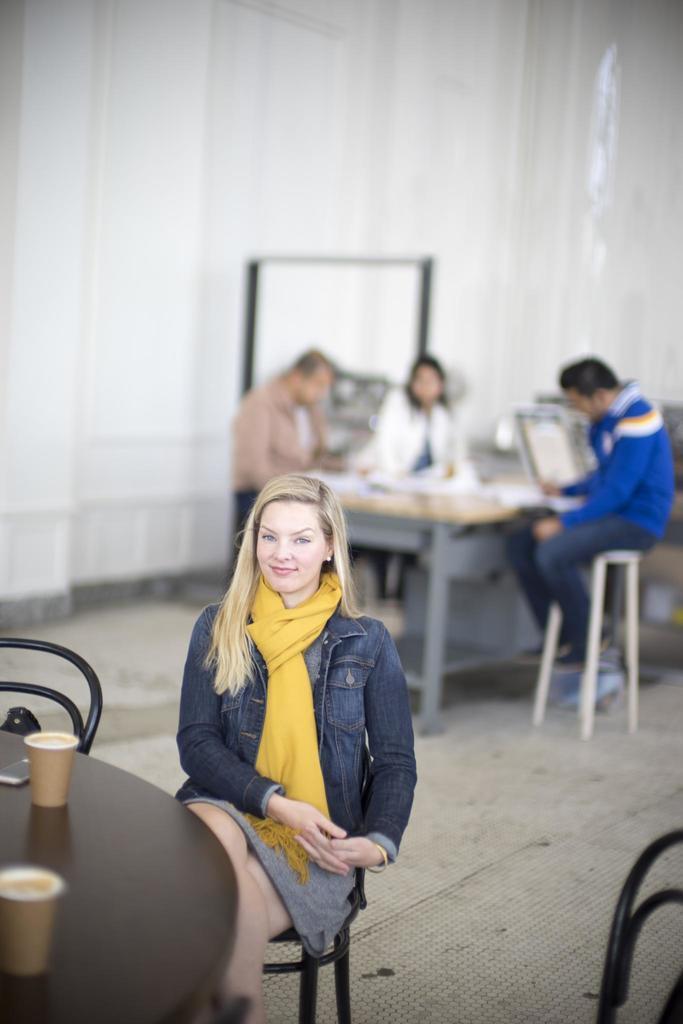Could you give a brief overview of what you see in this image? In the center of the image there is a lady sitting on a chair. On the left there is a table. There are glasses and a mobile placed on the table. There are chairs. In the background there are three people sitting around a table. 